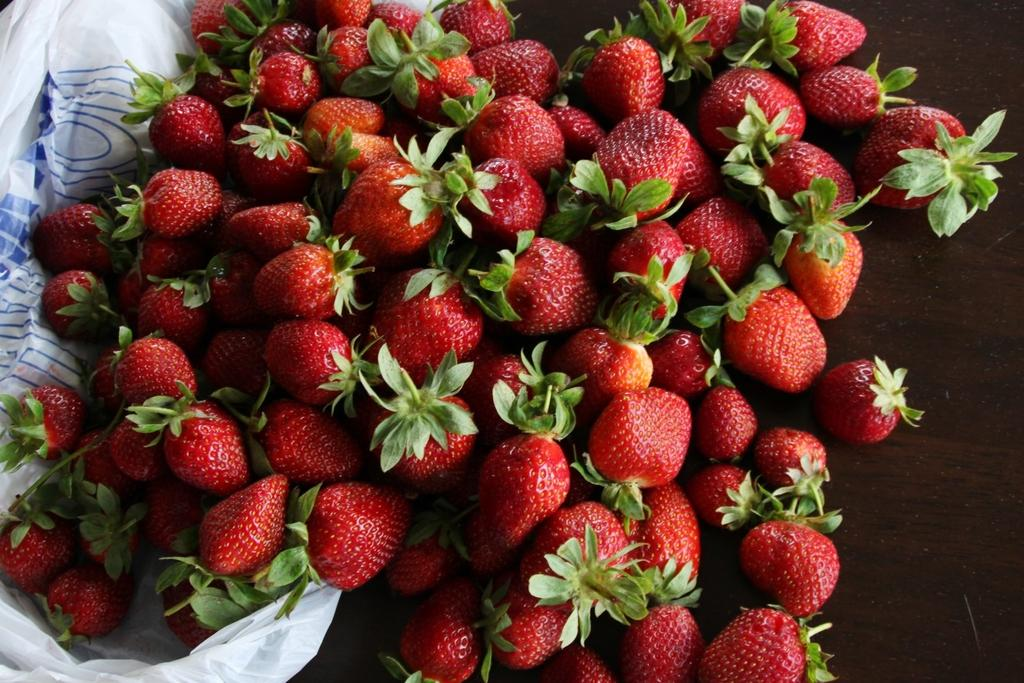What type of fruit can be seen in the image? There are strawberries in the image. What is covering the strawberries in the image? There is a plastic cover in the image. Where are the strawberries and plastic cover located? They are on a platform in the image. Can you see any stockings on the ground in the image? There is no mention of stockings or a ground in the image, so it cannot be determined if any stockings are present. 